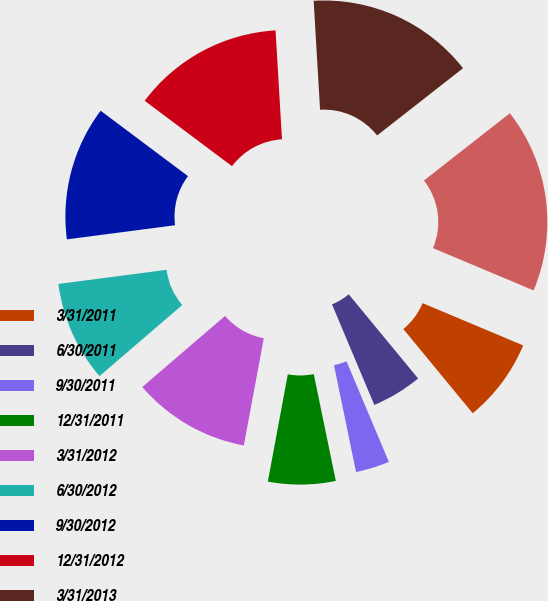Convert chart. <chart><loc_0><loc_0><loc_500><loc_500><pie_chart><fcel>3/31/2011<fcel>6/30/2011<fcel>9/30/2011<fcel>12/31/2011<fcel>3/31/2012<fcel>6/30/2012<fcel>9/30/2012<fcel>12/31/2012<fcel>3/31/2013<fcel>6/30/2013<nl><fcel>7.7%<fcel>4.63%<fcel>3.1%<fcel>6.17%<fcel>10.77%<fcel>9.23%<fcel>12.3%<fcel>13.83%<fcel>15.37%<fcel>16.9%<nl></chart> 